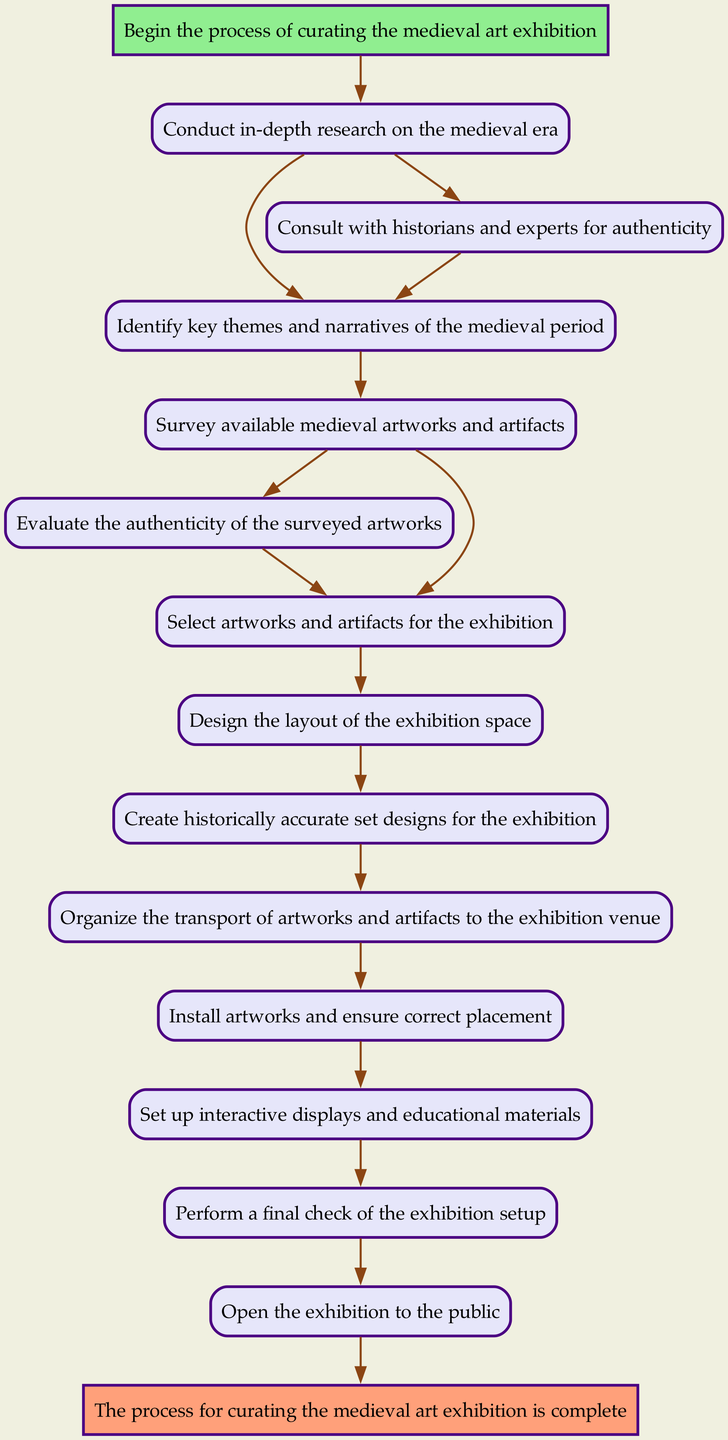What is the first step in the exhibition curation process? The first node in the diagram is labeled 'Start' and indicates the beginning of the process. The next node connected to 'Start' is 'ResearchMedievalPeriod'.
Answer: Research Medieval Period How many nodes are present in the diagram? Each unique step in the process is represented as a node. Counting each of them gives a total of 12 nodes in the diagram.
Answer: 12 What node follows 'SurveyAvailableArtworks'? The 'SurveyAvailableArtworks' node has two outgoing edges leading to 'EvaluateAuthenticity' and 'SelectArtworks'. Therefore, either of these could be the next step, but since we only seek one, we choose 'EvaluateAuthenticity' as it is the first one listed.
Answer: Evaluate Authenticity Which node leads to 'PerformFinalCheck'? The diagram shows that 'SetupInteractiveDisplays' is the node that directly connects to 'PerformFinalCheck', indicating it is the preceding step.
Answer: Setup Interactive Displays What are the final two steps in the process flow? The process flow ends with the nodes 'OpenExhibition' followed by 'End'. They are the last two steps indicating closure of the exhibition curation process.
Answer: Open Exhibition, End How does one ensure the authenticity of artworks during the curation process? Based on the flowchart, the step focused on ensuring authenticity is labeled 'EvaluateAuthenticity', which specifically deals with this task before selecting artworks.
Answer: Evaluate Authenticity Identify the step that involves arranging the exhibition space layout. The process node named 'DesignExhibitionLayout' is where the layout of the exhibition space is arranged after selecting the artworks.
Answer: Design Exhibition Layout What is the relationship between 'ConsultHistorians' and 'IdentifyKeyThemes'? 'ConsultHistorians' does not lead directly to 'IdentifyKeyThemes' but creates a loop back to it; confirming that consulting historians is part of refining the key themes in the process.
Answer: Loop back to Identify Key Themes Which specific node is responsible for the installation of artworks? The node specifically responsible for installing the artworks in the exhibition flow is labeled 'InstallArtworks', and it follows after organizing transport.
Answer: Install Artworks 